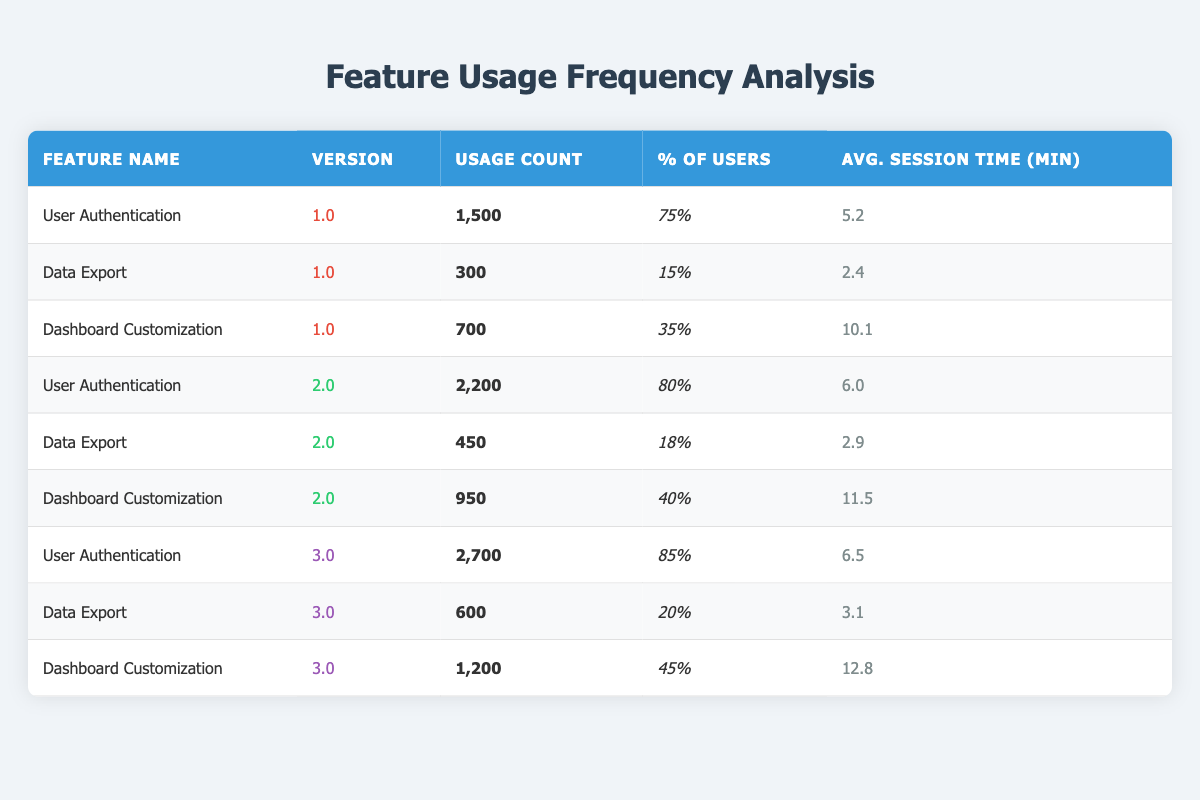What is the usage count for the feature "Data Export" in version 2.0? Looking at the row for "Data Export" under version 2.0, the usage count is clearly indicated as 450.
Answer: 450 Which feature had the highest percentage of users across all versions? By comparing the percentage of users for each feature across all versions, "User Authentication" has a maximum value of 85% in version 3.0, which is higher than any percentage for the other features.
Answer: User Authentication What is the average session time for "Dashboard Customization" across all versions? First, gather the session times for "Dashboard Customization": 10.1 (version 1.0), 11.5 (version 2.0), and 12.8 (version 3.0). Then, calculate the average: (10.1 + 11.5 + 12.8) / 3 = 11.47.
Answer: 11.47 Did the usage count for "User Authentication" increase in each version? Checking the usage counts: version 1.0 had 1500, version 2.0 had 2200, and version 3.0 had 2700. Since each subsequent version's count is greater than the previous, the statement is true.
Answer: Yes What is the difference in the average session time for "Data Export" between version 1.0 and version 3.0? For "Data Export", the average session time for version 1.0 is 2.4 minutes, and for version 3.0, it is 3.1 minutes. Thus, the difference is 3.1 - 2.4 = 0.7 minutes.
Answer: 0.7 minutes What feature has the lowest percentage of users in version 1.0? Reviewing the percentage of users in version 1.0, "Data Export" has the lowest percentage at 15%, compared to the other features' percentages of 75% and 35%.
Answer: Data Export How many total users utilized "Dashboard Customization" in version 3.0? Referring to "Dashboard Customization" in version 3.0, the row shows a usage count of 1200 users.
Answer: 1200 Is the average session time for "User Authentication" greater than that of "Data Export" in version 3.0? For "User Authentication" in version 3.0, the average session time is 6.5 minutes, whereas for "Data Export" in version 3.0, it is 3.1 minutes. Since 6.5 is greater than 3.1, the statement is true.
Answer: Yes What is the total usage count for "Data Export" across all versions? The usage counts for "Data Export" are 300 (version 1.0), 450 (version 2.0), and 600 (version 3.0). Summing these values gives 300 + 450 + 600 = 1350.
Answer: 1350 